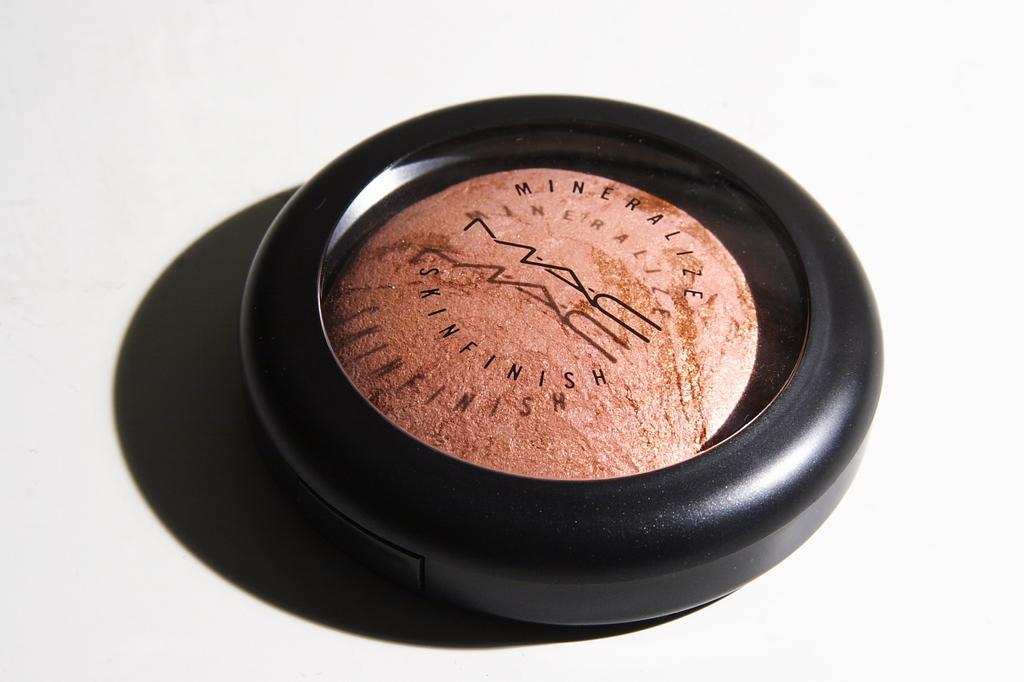<image>
Write a terse but informative summary of the picture. A container of MAC Skin finish makeup sits against a white background 